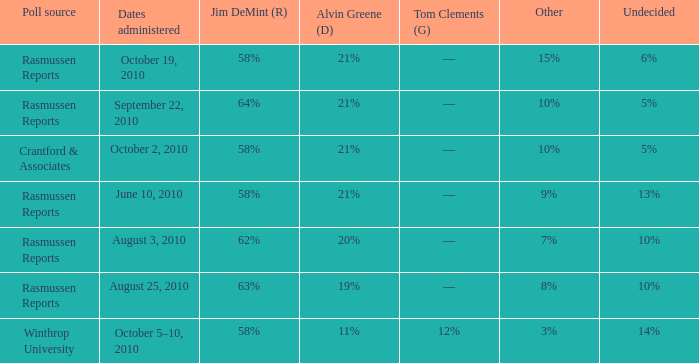What was the vote for Alvin Green when Jim DeMint was 62%? 20%. 